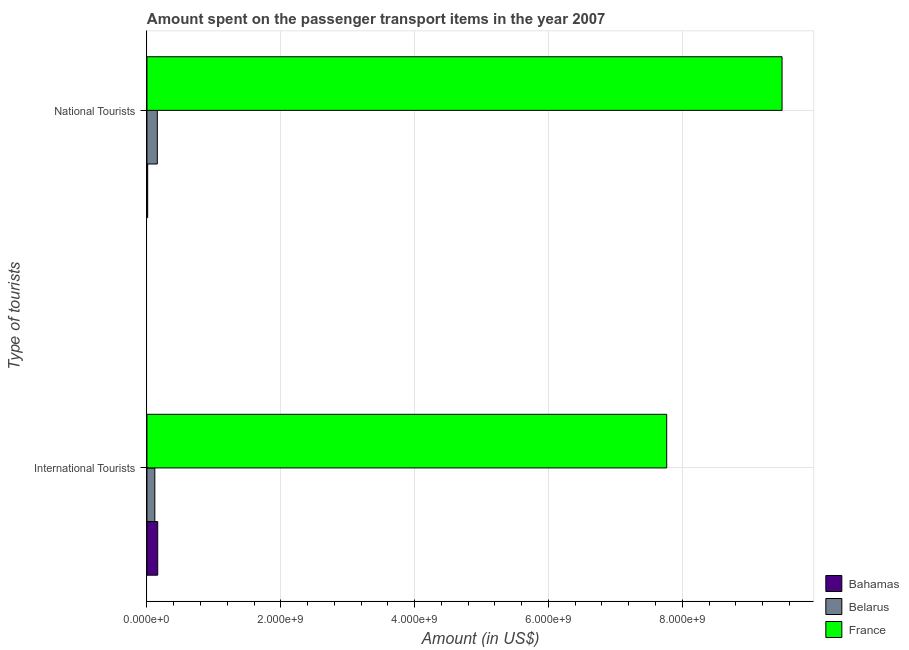How many different coloured bars are there?
Offer a very short reply. 3. Are the number of bars per tick equal to the number of legend labels?
Make the answer very short. Yes. What is the label of the 1st group of bars from the top?
Give a very brief answer. National Tourists. What is the amount spent on transport items of international tourists in Belarus?
Provide a succinct answer. 1.18e+08. Across all countries, what is the maximum amount spent on transport items of national tourists?
Provide a succinct answer. 9.49e+09. Across all countries, what is the minimum amount spent on transport items of national tourists?
Offer a very short reply. 1.10e+07. In which country was the amount spent on transport items of international tourists minimum?
Your answer should be very brief. Belarus. What is the total amount spent on transport items of national tourists in the graph?
Provide a short and direct response. 9.66e+09. What is the difference between the amount spent on transport items of international tourists in Belarus and that in France?
Keep it short and to the point. -7.65e+09. What is the difference between the amount spent on transport items of international tourists in Bahamas and the amount spent on transport items of national tourists in Belarus?
Offer a very short reply. 6.00e+06. What is the average amount spent on transport items of national tourists per country?
Offer a terse response. 3.22e+09. What is the difference between the amount spent on transport items of national tourists and amount spent on transport items of international tourists in France?
Your response must be concise. 1.72e+09. In how many countries, is the amount spent on transport items of national tourists greater than 400000000 US$?
Ensure brevity in your answer.  1. What is the ratio of the amount spent on transport items of international tourists in Bahamas to that in France?
Ensure brevity in your answer.  0.02. Is the amount spent on transport items of national tourists in Belarus less than that in Bahamas?
Offer a very short reply. No. In how many countries, is the amount spent on transport items of international tourists greater than the average amount spent on transport items of international tourists taken over all countries?
Your response must be concise. 1. What does the 1st bar from the top in International Tourists represents?
Your answer should be compact. France. What does the 1st bar from the bottom in International Tourists represents?
Give a very brief answer. Bahamas. How many countries are there in the graph?
Your answer should be very brief. 3. Are the values on the major ticks of X-axis written in scientific E-notation?
Your answer should be compact. Yes. Does the graph contain any zero values?
Offer a very short reply. No. Where does the legend appear in the graph?
Offer a terse response. Bottom right. How are the legend labels stacked?
Your response must be concise. Vertical. What is the title of the graph?
Keep it short and to the point. Amount spent on the passenger transport items in the year 2007. What is the label or title of the X-axis?
Make the answer very short. Amount (in US$). What is the label or title of the Y-axis?
Provide a succinct answer. Type of tourists. What is the Amount (in US$) in Bahamas in International Tourists?
Your answer should be compact. 1.61e+08. What is the Amount (in US$) of Belarus in International Tourists?
Provide a succinct answer. 1.18e+08. What is the Amount (in US$) in France in International Tourists?
Your answer should be compact. 7.77e+09. What is the Amount (in US$) in Bahamas in National Tourists?
Offer a very short reply. 1.10e+07. What is the Amount (in US$) of Belarus in National Tourists?
Your answer should be very brief. 1.55e+08. What is the Amount (in US$) in France in National Tourists?
Your answer should be compact. 9.49e+09. Across all Type of tourists, what is the maximum Amount (in US$) in Bahamas?
Your answer should be compact. 1.61e+08. Across all Type of tourists, what is the maximum Amount (in US$) of Belarus?
Offer a terse response. 1.55e+08. Across all Type of tourists, what is the maximum Amount (in US$) in France?
Provide a short and direct response. 9.49e+09. Across all Type of tourists, what is the minimum Amount (in US$) in Bahamas?
Offer a very short reply. 1.10e+07. Across all Type of tourists, what is the minimum Amount (in US$) in Belarus?
Offer a very short reply. 1.18e+08. Across all Type of tourists, what is the minimum Amount (in US$) of France?
Your answer should be compact. 7.77e+09. What is the total Amount (in US$) of Bahamas in the graph?
Offer a terse response. 1.72e+08. What is the total Amount (in US$) of Belarus in the graph?
Ensure brevity in your answer.  2.73e+08. What is the total Amount (in US$) in France in the graph?
Offer a very short reply. 1.73e+1. What is the difference between the Amount (in US$) of Bahamas in International Tourists and that in National Tourists?
Give a very brief answer. 1.50e+08. What is the difference between the Amount (in US$) of Belarus in International Tourists and that in National Tourists?
Give a very brief answer. -3.70e+07. What is the difference between the Amount (in US$) of France in International Tourists and that in National Tourists?
Offer a terse response. -1.72e+09. What is the difference between the Amount (in US$) of Bahamas in International Tourists and the Amount (in US$) of Belarus in National Tourists?
Offer a very short reply. 6.00e+06. What is the difference between the Amount (in US$) in Bahamas in International Tourists and the Amount (in US$) in France in National Tourists?
Ensure brevity in your answer.  -9.33e+09. What is the difference between the Amount (in US$) of Belarus in International Tourists and the Amount (in US$) of France in National Tourists?
Offer a terse response. -9.37e+09. What is the average Amount (in US$) of Bahamas per Type of tourists?
Your answer should be very brief. 8.60e+07. What is the average Amount (in US$) of Belarus per Type of tourists?
Offer a terse response. 1.36e+08. What is the average Amount (in US$) in France per Type of tourists?
Provide a short and direct response. 8.63e+09. What is the difference between the Amount (in US$) in Bahamas and Amount (in US$) in Belarus in International Tourists?
Give a very brief answer. 4.30e+07. What is the difference between the Amount (in US$) in Bahamas and Amount (in US$) in France in International Tourists?
Keep it short and to the point. -7.61e+09. What is the difference between the Amount (in US$) in Belarus and Amount (in US$) in France in International Tourists?
Give a very brief answer. -7.65e+09. What is the difference between the Amount (in US$) in Bahamas and Amount (in US$) in Belarus in National Tourists?
Your answer should be compact. -1.44e+08. What is the difference between the Amount (in US$) of Bahamas and Amount (in US$) of France in National Tourists?
Make the answer very short. -9.48e+09. What is the difference between the Amount (in US$) in Belarus and Amount (in US$) in France in National Tourists?
Give a very brief answer. -9.34e+09. What is the ratio of the Amount (in US$) of Bahamas in International Tourists to that in National Tourists?
Make the answer very short. 14.64. What is the ratio of the Amount (in US$) of Belarus in International Tourists to that in National Tourists?
Offer a very short reply. 0.76. What is the ratio of the Amount (in US$) in France in International Tourists to that in National Tourists?
Your answer should be compact. 0.82. What is the difference between the highest and the second highest Amount (in US$) of Bahamas?
Ensure brevity in your answer.  1.50e+08. What is the difference between the highest and the second highest Amount (in US$) of Belarus?
Offer a terse response. 3.70e+07. What is the difference between the highest and the second highest Amount (in US$) in France?
Offer a very short reply. 1.72e+09. What is the difference between the highest and the lowest Amount (in US$) of Bahamas?
Offer a terse response. 1.50e+08. What is the difference between the highest and the lowest Amount (in US$) of Belarus?
Your response must be concise. 3.70e+07. What is the difference between the highest and the lowest Amount (in US$) of France?
Give a very brief answer. 1.72e+09. 